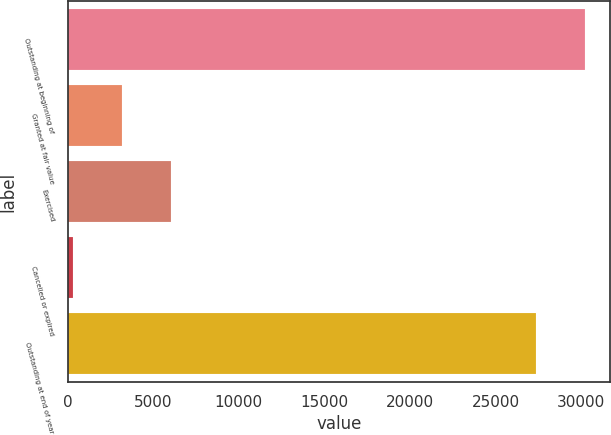<chart> <loc_0><loc_0><loc_500><loc_500><bar_chart><fcel>Outstanding at beginning of<fcel>Granted at fair value<fcel>Exercised<fcel>Cancelled or expired<fcel>Outstanding at end of year<nl><fcel>30206.8<fcel>3190.45<fcel>6052.6<fcel>328.3<fcel>27344.7<nl></chart> 